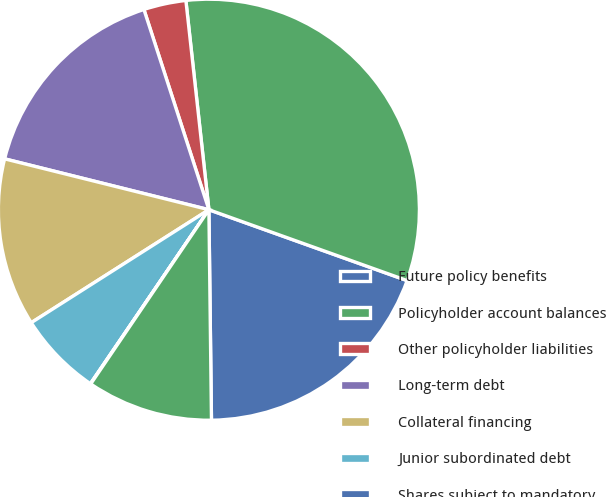Convert chart. <chart><loc_0><loc_0><loc_500><loc_500><pie_chart><fcel>Future policy benefits<fcel>Policyholder account balances<fcel>Other policyholder liabilities<fcel>Long-term debt<fcel>Collateral financing<fcel>Junior subordinated debt<fcel>Shares subject to mandatory<fcel>Commitments to lend funds<nl><fcel>19.34%<fcel>32.21%<fcel>3.25%<fcel>16.12%<fcel>12.9%<fcel>6.47%<fcel>0.03%<fcel>9.68%<nl></chart> 